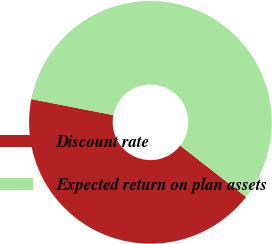Convert chart. <chart><loc_0><loc_0><loc_500><loc_500><pie_chart><fcel>Discount rate<fcel>Expected return on plan assets<nl><fcel>42.53%<fcel>57.47%<nl></chart> 